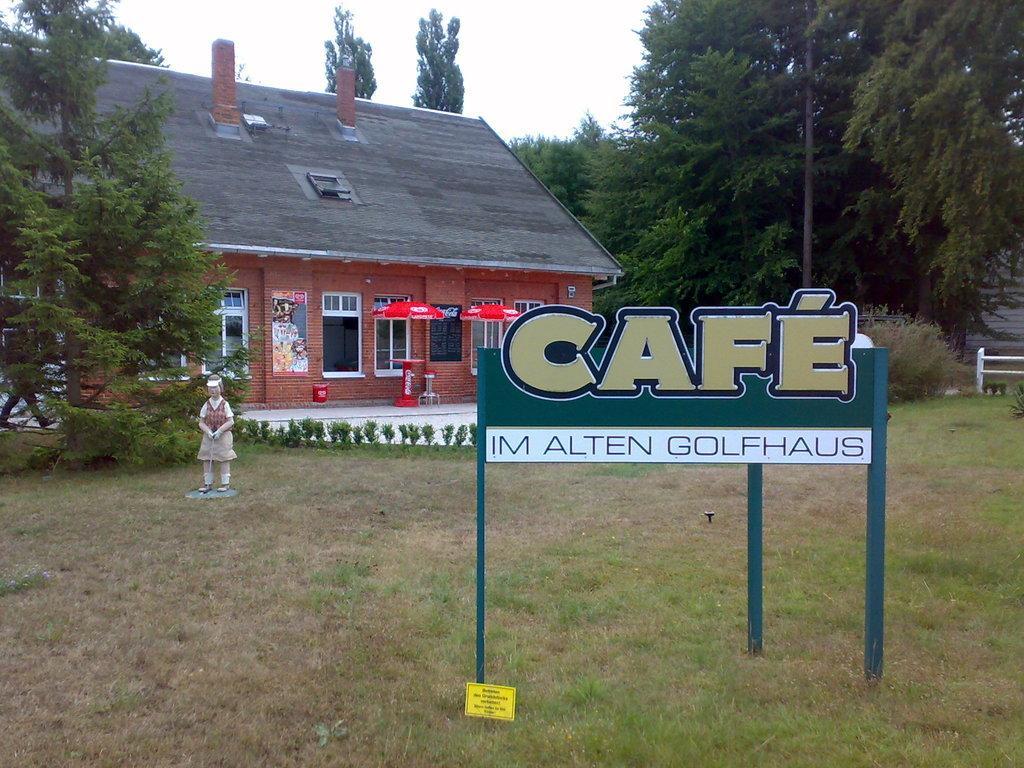Please provide a concise description of this image. In this picture we can see the grass, name boards, plants, statue, poster, umbrellas, trees, building with windows, some objects and in the background we can see the sky. 